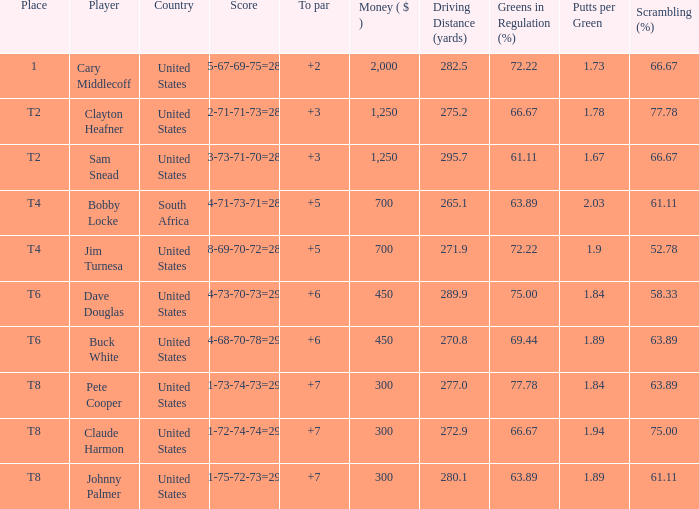What Country is Player Sam Snead with a To par of less than 5 from? United States. 